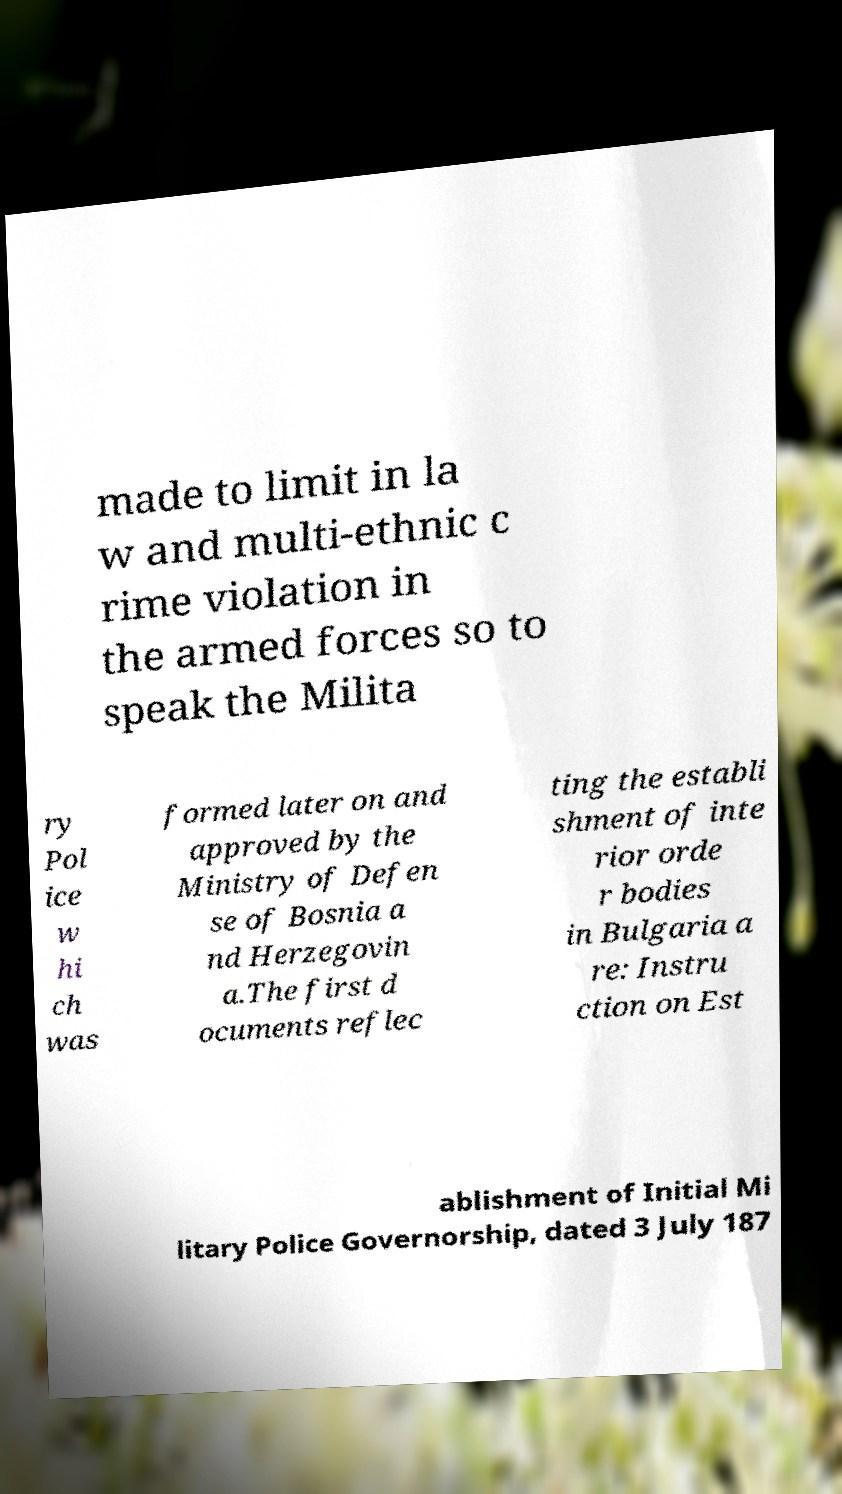Could you extract and type out the text from this image? made to limit in la w and multi-ethnic c rime violation in the armed forces so to speak the Milita ry Pol ice w hi ch was formed later on and approved by the Ministry of Defen se of Bosnia a nd Herzegovin a.The first d ocuments reflec ting the establi shment of inte rior orde r bodies in Bulgaria a re: Instru ction on Est ablishment of Initial Mi litary Police Governorship, dated 3 July 187 